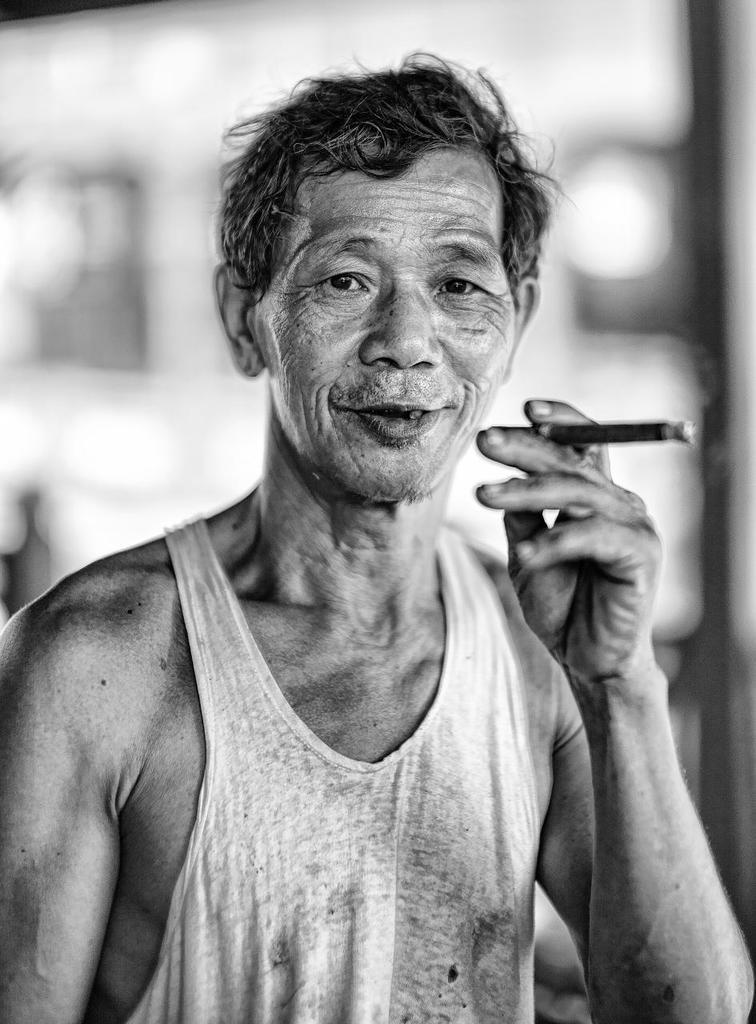What is the color scheme of the image? The image is black and white. Can you describe the main subject in the image? There is a person in the image. What is the person holding in the image? The person is holding a cigar. Where is the person located in the image? The person is in the middle of the image. How many feathers can be seen on the zebra in the image? There is no zebra present in the image, and therefore no feathers can be seen. 